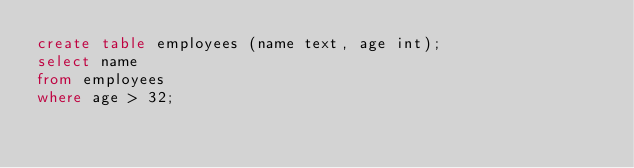Convert code to text. <code><loc_0><loc_0><loc_500><loc_500><_SQL_>create table employees (name text, age int);
select name
from employees
where age > 32;
</code> 